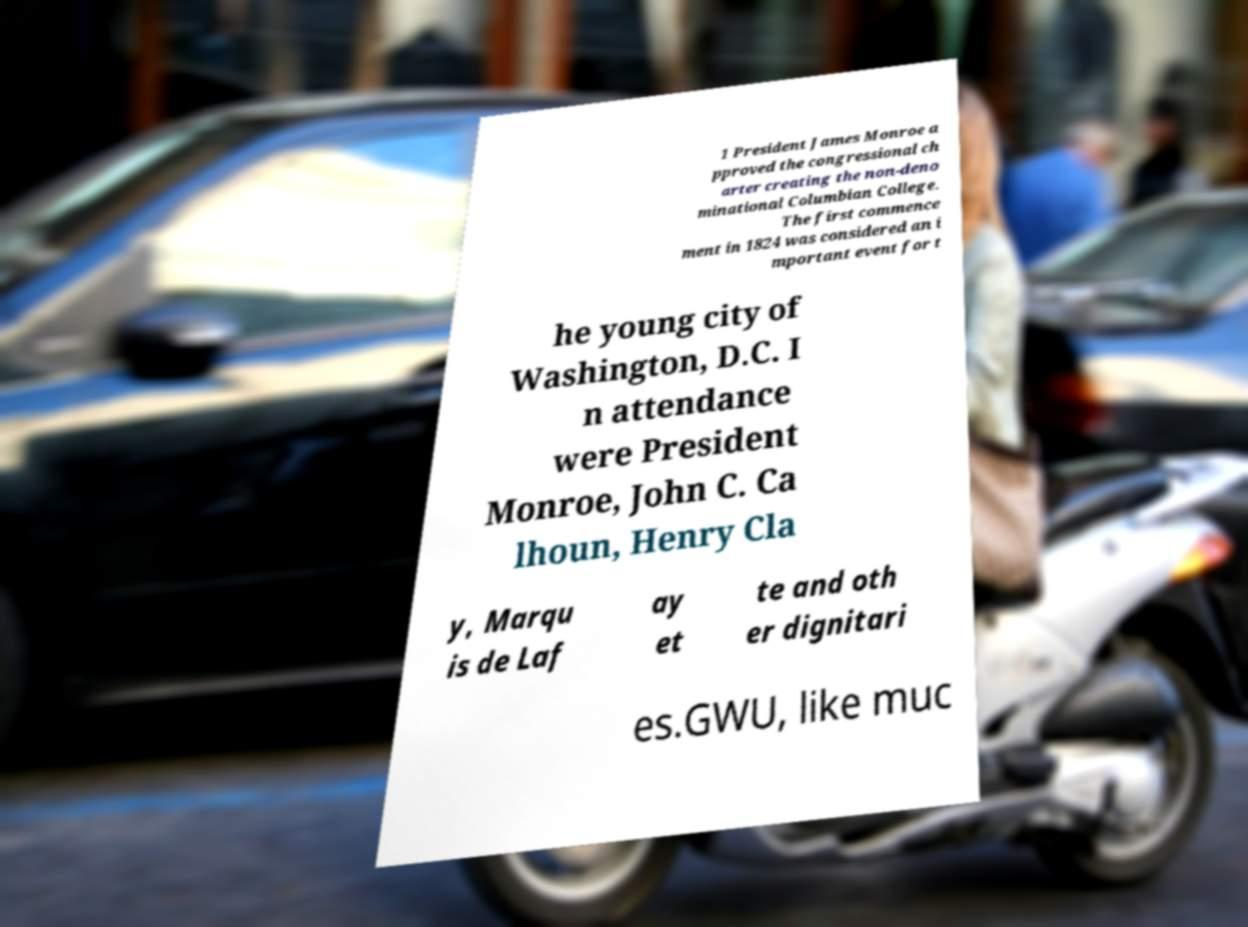For documentation purposes, I need the text within this image transcribed. Could you provide that? 1 President James Monroe a pproved the congressional ch arter creating the non-deno minational Columbian College. The first commence ment in 1824 was considered an i mportant event for t he young city of Washington, D.C. I n attendance were President Monroe, John C. Ca lhoun, Henry Cla y, Marqu is de Laf ay et te and oth er dignitari es.GWU, like muc 